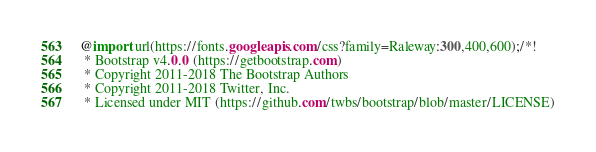<code> <loc_0><loc_0><loc_500><loc_500><_CSS_>@import url(https://fonts.googleapis.com/css?family=Raleway:300,400,600);/*!
 * Bootstrap v4.0.0 (https://getbootstrap.com)
 * Copyright 2011-2018 The Bootstrap Authors
 * Copyright 2011-2018 Twitter, Inc.
 * Licensed under MIT (https://github.com/twbs/bootstrap/blob/master/LICENSE)</code> 